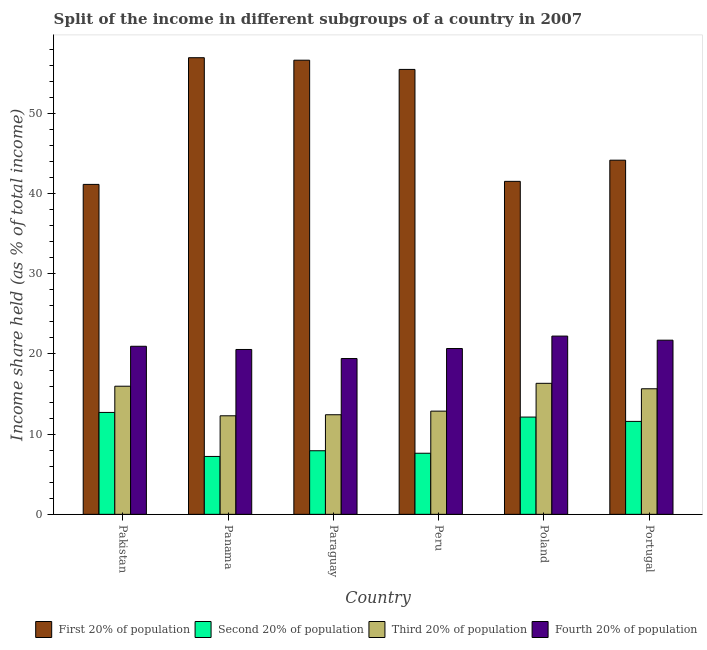How many groups of bars are there?
Keep it short and to the point. 6. Are the number of bars per tick equal to the number of legend labels?
Your response must be concise. Yes. How many bars are there on the 2nd tick from the left?
Ensure brevity in your answer.  4. How many bars are there on the 6th tick from the right?
Your answer should be very brief. 4. In how many cases, is the number of bars for a given country not equal to the number of legend labels?
Your answer should be very brief. 0. What is the share of the income held by third 20% of the population in Portugal?
Offer a terse response. 15.66. Across all countries, what is the maximum share of the income held by first 20% of the population?
Make the answer very short. 56.95. Across all countries, what is the minimum share of the income held by first 20% of the population?
Give a very brief answer. 41.15. In which country was the share of the income held by first 20% of the population maximum?
Your answer should be very brief. Panama. In which country was the share of the income held by first 20% of the population minimum?
Keep it short and to the point. Pakistan. What is the total share of the income held by fourth 20% of the population in the graph?
Your response must be concise. 125.58. What is the difference between the share of the income held by third 20% of the population in Panama and that in Peru?
Keep it short and to the point. -0.58. What is the difference between the share of the income held by second 20% of the population in Panama and the share of the income held by third 20% of the population in Pakistan?
Ensure brevity in your answer.  -8.76. What is the average share of the income held by fourth 20% of the population per country?
Make the answer very short. 20.93. What is the difference between the share of the income held by first 20% of the population and share of the income held by second 20% of the population in Portugal?
Your answer should be compact. 32.58. What is the ratio of the share of the income held by fourth 20% of the population in Pakistan to that in Panama?
Your response must be concise. 1.02. What is the difference between the highest and the second highest share of the income held by second 20% of the population?
Provide a succinct answer. 0.58. What is the difference between the highest and the lowest share of the income held by fourth 20% of the population?
Provide a succinct answer. 2.8. What does the 1st bar from the left in Peru represents?
Your answer should be very brief. First 20% of population. What does the 3rd bar from the right in Peru represents?
Provide a succinct answer. Second 20% of population. Is it the case that in every country, the sum of the share of the income held by first 20% of the population and share of the income held by second 20% of the population is greater than the share of the income held by third 20% of the population?
Offer a very short reply. Yes. How many bars are there?
Offer a terse response. 24. Are all the bars in the graph horizontal?
Give a very brief answer. No. How many countries are there in the graph?
Offer a very short reply. 6. What is the difference between two consecutive major ticks on the Y-axis?
Offer a very short reply. 10. Are the values on the major ticks of Y-axis written in scientific E-notation?
Your response must be concise. No. Does the graph contain grids?
Your answer should be compact. No. Where does the legend appear in the graph?
Provide a succinct answer. Bottom right. How many legend labels are there?
Offer a very short reply. 4. How are the legend labels stacked?
Offer a terse response. Horizontal. What is the title of the graph?
Make the answer very short. Split of the income in different subgroups of a country in 2007. What is the label or title of the Y-axis?
Your answer should be very brief. Income share held (as % of total income). What is the Income share held (as % of total income) in First 20% of population in Pakistan?
Your answer should be very brief. 41.15. What is the Income share held (as % of total income) in Second 20% of population in Pakistan?
Your answer should be very brief. 12.71. What is the Income share held (as % of total income) of Third 20% of population in Pakistan?
Keep it short and to the point. 15.98. What is the Income share held (as % of total income) in Fourth 20% of population in Pakistan?
Provide a succinct answer. 20.96. What is the Income share held (as % of total income) of First 20% of population in Panama?
Your answer should be compact. 56.95. What is the Income share held (as % of total income) of Second 20% of population in Panama?
Give a very brief answer. 7.22. What is the Income share held (as % of total income) in Third 20% of population in Panama?
Your answer should be very brief. 12.29. What is the Income share held (as % of total income) of Fourth 20% of population in Panama?
Provide a succinct answer. 20.56. What is the Income share held (as % of total income) of First 20% of population in Paraguay?
Keep it short and to the point. 56.64. What is the Income share held (as % of total income) in Second 20% of population in Paraguay?
Ensure brevity in your answer.  7.93. What is the Income share held (as % of total income) of Third 20% of population in Paraguay?
Offer a very short reply. 12.42. What is the Income share held (as % of total income) in Fourth 20% of population in Paraguay?
Provide a succinct answer. 19.43. What is the Income share held (as % of total income) in First 20% of population in Peru?
Keep it short and to the point. 55.49. What is the Income share held (as % of total income) of Second 20% of population in Peru?
Keep it short and to the point. 7.62. What is the Income share held (as % of total income) in Third 20% of population in Peru?
Keep it short and to the point. 12.87. What is the Income share held (as % of total income) in Fourth 20% of population in Peru?
Offer a terse response. 20.68. What is the Income share held (as % of total income) in First 20% of population in Poland?
Your response must be concise. 41.53. What is the Income share held (as % of total income) in Second 20% of population in Poland?
Your answer should be very brief. 12.13. What is the Income share held (as % of total income) of Third 20% of population in Poland?
Keep it short and to the point. 16.34. What is the Income share held (as % of total income) of Fourth 20% of population in Poland?
Make the answer very short. 22.23. What is the Income share held (as % of total income) in First 20% of population in Portugal?
Keep it short and to the point. 44.17. What is the Income share held (as % of total income) in Second 20% of population in Portugal?
Offer a terse response. 11.59. What is the Income share held (as % of total income) in Third 20% of population in Portugal?
Your answer should be compact. 15.66. What is the Income share held (as % of total income) in Fourth 20% of population in Portugal?
Give a very brief answer. 21.72. Across all countries, what is the maximum Income share held (as % of total income) in First 20% of population?
Offer a terse response. 56.95. Across all countries, what is the maximum Income share held (as % of total income) in Second 20% of population?
Ensure brevity in your answer.  12.71. Across all countries, what is the maximum Income share held (as % of total income) in Third 20% of population?
Keep it short and to the point. 16.34. Across all countries, what is the maximum Income share held (as % of total income) of Fourth 20% of population?
Offer a terse response. 22.23. Across all countries, what is the minimum Income share held (as % of total income) in First 20% of population?
Keep it short and to the point. 41.15. Across all countries, what is the minimum Income share held (as % of total income) of Second 20% of population?
Offer a terse response. 7.22. Across all countries, what is the minimum Income share held (as % of total income) of Third 20% of population?
Provide a short and direct response. 12.29. Across all countries, what is the minimum Income share held (as % of total income) in Fourth 20% of population?
Your answer should be compact. 19.43. What is the total Income share held (as % of total income) in First 20% of population in the graph?
Keep it short and to the point. 295.93. What is the total Income share held (as % of total income) in Second 20% of population in the graph?
Give a very brief answer. 59.2. What is the total Income share held (as % of total income) of Third 20% of population in the graph?
Give a very brief answer. 85.56. What is the total Income share held (as % of total income) in Fourth 20% of population in the graph?
Ensure brevity in your answer.  125.58. What is the difference between the Income share held (as % of total income) of First 20% of population in Pakistan and that in Panama?
Your answer should be very brief. -15.8. What is the difference between the Income share held (as % of total income) of Second 20% of population in Pakistan and that in Panama?
Your response must be concise. 5.49. What is the difference between the Income share held (as % of total income) in Third 20% of population in Pakistan and that in Panama?
Keep it short and to the point. 3.69. What is the difference between the Income share held (as % of total income) in First 20% of population in Pakistan and that in Paraguay?
Provide a succinct answer. -15.49. What is the difference between the Income share held (as % of total income) of Second 20% of population in Pakistan and that in Paraguay?
Keep it short and to the point. 4.78. What is the difference between the Income share held (as % of total income) of Third 20% of population in Pakistan and that in Paraguay?
Offer a very short reply. 3.56. What is the difference between the Income share held (as % of total income) in Fourth 20% of population in Pakistan and that in Paraguay?
Your answer should be compact. 1.53. What is the difference between the Income share held (as % of total income) of First 20% of population in Pakistan and that in Peru?
Your answer should be very brief. -14.34. What is the difference between the Income share held (as % of total income) in Second 20% of population in Pakistan and that in Peru?
Ensure brevity in your answer.  5.09. What is the difference between the Income share held (as % of total income) of Third 20% of population in Pakistan and that in Peru?
Your answer should be very brief. 3.11. What is the difference between the Income share held (as % of total income) in Fourth 20% of population in Pakistan and that in Peru?
Provide a succinct answer. 0.28. What is the difference between the Income share held (as % of total income) in First 20% of population in Pakistan and that in Poland?
Keep it short and to the point. -0.38. What is the difference between the Income share held (as % of total income) in Second 20% of population in Pakistan and that in Poland?
Ensure brevity in your answer.  0.58. What is the difference between the Income share held (as % of total income) in Third 20% of population in Pakistan and that in Poland?
Make the answer very short. -0.36. What is the difference between the Income share held (as % of total income) of Fourth 20% of population in Pakistan and that in Poland?
Provide a succinct answer. -1.27. What is the difference between the Income share held (as % of total income) of First 20% of population in Pakistan and that in Portugal?
Your response must be concise. -3.02. What is the difference between the Income share held (as % of total income) of Second 20% of population in Pakistan and that in Portugal?
Give a very brief answer. 1.12. What is the difference between the Income share held (as % of total income) of Third 20% of population in Pakistan and that in Portugal?
Provide a succinct answer. 0.32. What is the difference between the Income share held (as % of total income) in Fourth 20% of population in Pakistan and that in Portugal?
Offer a very short reply. -0.76. What is the difference between the Income share held (as % of total income) in First 20% of population in Panama and that in Paraguay?
Make the answer very short. 0.31. What is the difference between the Income share held (as % of total income) of Second 20% of population in Panama and that in Paraguay?
Give a very brief answer. -0.71. What is the difference between the Income share held (as % of total income) of Third 20% of population in Panama and that in Paraguay?
Your response must be concise. -0.13. What is the difference between the Income share held (as % of total income) in Fourth 20% of population in Panama and that in Paraguay?
Your answer should be compact. 1.13. What is the difference between the Income share held (as % of total income) in First 20% of population in Panama and that in Peru?
Your answer should be compact. 1.46. What is the difference between the Income share held (as % of total income) in Second 20% of population in Panama and that in Peru?
Your answer should be compact. -0.4. What is the difference between the Income share held (as % of total income) of Third 20% of population in Panama and that in Peru?
Your answer should be compact. -0.58. What is the difference between the Income share held (as % of total income) in Fourth 20% of population in Panama and that in Peru?
Offer a very short reply. -0.12. What is the difference between the Income share held (as % of total income) in First 20% of population in Panama and that in Poland?
Offer a very short reply. 15.42. What is the difference between the Income share held (as % of total income) in Second 20% of population in Panama and that in Poland?
Ensure brevity in your answer.  -4.91. What is the difference between the Income share held (as % of total income) in Third 20% of population in Panama and that in Poland?
Ensure brevity in your answer.  -4.05. What is the difference between the Income share held (as % of total income) in Fourth 20% of population in Panama and that in Poland?
Provide a short and direct response. -1.67. What is the difference between the Income share held (as % of total income) in First 20% of population in Panama and that in Portugal?
Keep it short and to the point. 12.78. What is the difference between the Income share held (as % of total income) of Second 20% of population in Panama and that in Portugal?
Make the answer very short. -4.37. What is the difference between the Income share held (as % of total income) of Third 20% of population in Panama and that in Portugal?
Provide a short and direct response. -3.37. What is the difference between the Income share held (as % of total income) of Fourth 20% of population in Panama and that in Portugal?
Your answer should be compact. -1.16. What is the difference between the Income share held (as % of total income) of First 20% of population in Paraguay and that in Peru?
Offer a terse response. 1.15. What is the difference between the Income share held (as % of total income) in Second 20% of population in Paraguay and that in Peru?
Provide a short and direct response. 0.31. What is the difference between the Income share held (as % of total income) of Third 20% of population in Paraguay and that in Peru?
Offer a very short reply. -0.45. What is the difference between the Income share held (as % of total income) in Fourth 20% of population in Paraguay and that in Peru?
Offer a terse response. -1.25. What is the difference between the Income share held (as % of total income) in First 20% of population in Paraguay and that in Poland?
Your answer should be very brief. 15.11. What is the difference between the Income share held (as % of total income) of Second 20% of population in Paraguay and that in Poland?
Give a very brief answer. -4.2. What is the difference between the Income share held (as % of total income) in Third 20% of population in Paraguay and that in Poland?
Ensure brevity in your answer.  -3.92. What is the difference between the Income share held (as % of total income) of First 20% of population in Paraguay and that in Portugal?
Give a very brief answer. 12.47. What is the difference between the Income share held (as % of total income) in Second 20% of population in Paraguay and that in Portugal?
Your response must be concise. -3.66. What is the difference between the Income share held (as % of total income) of Third 20% of population in Paraguay and that in Portugal?
Your answer should be very brief. -3.24. What is the difference between the Income share held (as % of total income) in Fourth 20% of population in Paraguay and that in Portugal?
Your answer should be very brief. -2.29. What is the difference between the Income share held (as % of total income) in First 20% of population in Peru and that in Poland?
Keep it short and to the point. 13.96. What is the difference between the Income share held (as % of total income) of Second 20% of population in Peru and that in Poland?
Your answer should be very brief. -4.51. What is the difference between the Income share held (as % of total income) in Third 20% of population in Peru and that in Poland?
Make the answer very short. -3.47. What is the difference between the Income share held (as % of total income) in Fourth 20% of population in Peru and that in Poland?
Keep it short and to the point. -1.55. What is the difference between the Income share held (as % of total income) in First 20% of population in Peru and that in Portugal?
Your answer should be very brief. 11.32. What is the difference between the Income share held (as % of total income) of Second 20% of population in Peru and that in Portugal?
Your answer should be compact. -3.97. What is the difference between the Income share held (as % of total income) of Third 20% of population in Peru and that in Portugal?
Provide a short and direct response. -2.79. What is the difference between the Income share held (as % of total income) of Fourth 20% of population in Peru and that in Portugal?
Make the answer very short. -1.04. What is the difference between the Income share held (as % of total income) in First 20% of population in Poland and that in Portugal?
Your answer should be compact. -2.64. What is the difference between the Income share held (as % of total income) in Second 20% of population in Poland and that in Portugal?
Keep it short and to the point. 0.54. What is the difference between the Income share held (as % of total income) in Third 20% of population in Poland and that in Portugal?
Keep it short and to the point. 0.68. What is the difference between the Income share held (as % of total income) in Fourth 20% of population in Poland and that in Portugal?
Your answer should be very brief. 0.51. What is the difference between the Income share held (as % of total income) in First 20% of population in Pakistan and the Income share held (as % of total income) in Second 20% of population in Panama?
Ensure brevity in your answer.  33.93. What is the difference between the Income share held (as % of total income) of First 20% of population in Pakistan and the Income share held (as % of total income) of Third 20% of population in Panama?
Make the answer very short. 28.86. What is the difference between the Income share held (as % of total income) of First 20% of population in Pakistan and the Income share held (as % of total income) of Fourth 20% of population in Panama?
Your answer should be very brief. 20.59. What is the difference between the Income share held (as % of total income) in Second 20% of population in Pakistan and the Income share held (as % of total income) in Third 20% of population in Panama?
Your answer should be very brief. 0.42. What is the difference between the Income share held (as % of total income) of Second 20% of population in Pakistan and the Income share held (as % of total income) of Fourth 20% of population in Panama?
Offer a terse response. -7.85. What is the difference between the Income share held (as % of total income) in Third 20% of population in Pakistan and the Income share held (as % of total income) in Fourth 20% of population in Panama?
Your answer should be very brief. -4.58. What is the difference between the Income share held (as % of total income) of First 20% of population in Pakistan and the Income share held (as % of total income) of Second 20% of population in Paraguay?
Your response must be concise. 33.22. What is the difference between the Income share held (as % of total income) in First 20% of population in Pakistan and the Income share held (as % of total income) in Third 20% of population in Paraguay?
Provide a succinct answer. 28.73. What is the difference between the Income share held (as % of total income) in First 20% of population in Pakistan and the Income share held (as % of total income) in Fourth 20% of population in Paraguay?
Offer a terse response. 21.72. What is the difference between the Income share held (as % of total income) in Second 20% of population in Pakistan and the Income share held (as % of total income) in Third 20% of population in Paraguay?
Offer a very short reply. 0.29. What is the difference between the Income share held (as % of total income) of Second 20% of population in Pakistan and the Income share held (as % of total income) of Fourth 20% of population in Paraguay?
Your answer should be very brief. -6.72. What is the difference between the Income share held (as % of total income) in Third 20% of population in Pakistan and the Income share held (as % of total income) in Fourth 20% of population in Paraguay?
Ensure brevity in your answer.  -3.45. What is the difference between the Income share held (as % of total income) in First 20% of population in Pakistan and the Income share held (as % of total income) in Second 20% of population in Peru?
Ensure brevity in your answer.  33.53. What is the difference between the Income share held (as % of total income) in First 20% of population in Pakistan and the Income share held (as % of total income) in Third 20% of population in Peru?
Offer a very short reply. 28.28. What is the difference between the Income share held (as % of total income) in First 20% of population in Pakistan and the Income share held (as % of total income) in Fourth 20% of population in Peru?
Offer a very short reply. 20.47. What is the difference between the Income share held (as % of total income) in Second 20% of population in Pakistan and the Income share held (as % of total income) in Third 20% of population in Peru?
Provide a succinct answer. -0.16. What is the difference between the Income share held (as % of total income) of Second 20% of population in Pakistan and the Income share held (as % of total income) of Fourth 20% of population in Peru?
Give a very brief answer. -7.97. What is the difference between the Income share held (as % of total income) in First 20% of population in Pakistan and the Income share held (as % of total income) in Second 20% of population in Poland?
Your answer should be very brief. 29.02. What is the difference between the Income share held (as % of total income) of First 20% of population in Pakistan and the Income share held (as % of total income) of Third 20% of population in Poland?
Your answer should be very brief. 24.81. What is the difference between the Income share held (as % of total income) in First 20% of population in Pakistan and the Income share held (as % of total income) in Fourth 20% of population in Poland?
Your answer should be compact. 18.92. What is the difference between the Income share held (as % of total income) in Second 20% of population in Pakistan and the Income share held (as % of total income) in Third 20% of population in Poland?
Offer a terse response. -3.63. What is the difference between the Income share held (as % of total income) in Second 20% of population in Pakistan and the Income share held (as % of total income) in Fourth 20% of population in Poland?
Your answer should be compact. -9.52. What is the difference between the Income share held (as % of total income) of Third 20% of population in Pakistan and the Income share held (as % of total income) of Fourth 20% of population in Poland?
Ensure brevity in your answer.  -6.25. What is the difference between the Income share held (as % of total income) in First 20% of population in Pakistan and the Income share held (as % of total income) in Second 20% of population in Portugal?
Your response must be concise. 29.56. What is the difference between the Income share held (as % of total income) in First 20% of population in Pakistan and the Income share held (as % of total income) in Third 20% of population in Portugal?
Provide a succinct answer. 25.49. What is the difference between the Income share held (as % of total income) of First 20% of population in Pakistan and the Income share held (as % of total income) of Fourth 20% of population in Portugal?
Offer a very short reply. 19.43. What is the difference between the Income share held (as % of total income) of Second 20% of population in Pakistan and the Income share held (as % of total income) of Third 20% of population in Portugal?
Provide a succinct answer. -2.95. What is the difference between the Income share held (as % of total income) in Second 20% of population in Pakistan and the Income share held (as % of total income) in Fourth 20% of population in Portugal?
Provide a succinct answer. -9.01. What is the difference between the Income share held (as % of total income) in Third 20% of population in Pakistan and the Income share held (as % of total income) in Fourth 20% of population in Portugal?
Make the answer very short. -5.74. What is the difference between the Income share held (as % of total income) in First 20% of population in Panama and the Income share held (as % of total income) in Second 20% of population in Paraguay?
Your response must be concise. 49.02. What is the difference between the Income share held (as % of total income) in First 20% of population in Panama and the Income share held (as % of total income) in Third 20% of population in Paraguay?
Your answer should be very brief. 44.53. What is the difference between the Income share held (as % of total income) in First 20% of population in Panama and the Income share held (as % of total income) in Fourth 20% of population in Paraguay?
Offer a very short reply. 37.52. What is the difference between the Income share held (as % of total income) in Second 20% of population in Panama and the Income share held (as % of total income) in Third 20% of population in Paraguay?
Provide a succinct answer. -5.2. What is the difference between the Income share held (as % of total income) in Second 20% of population in Panama and the Income share held (as % of total income) in Fourth 20% of population in Paraguay?
Make the answer very short. -12.21. What is the difference between the Income share held (as % of total income) of Third 20% of population in Panama and the Income share held (as % of total income) of Fourth 20% of population in Paraguay?
Provide a short and direct response. -7.14. What is the difference between the Income share held (as % of total income) in First 20% of population in Panama and the Income share held (as % of total income) in Second 20% of population in Peru?
Provide a succinct answer. 49.33. What is the difference between the Income share held (as % of total income) of First 20% of population in Panama and the Income share held (as % of total income) of Third 20% of population in Peru?
Offer a very short reply. 44.08. What is the difference between the Income share held (as % of total income) of First 20% of population in Panama and the Income share held (as % of total income) of Fourth 20% of population in Peru?
Give a very brief answer. 36.27. What is the difference between the Income share held (as % of total income) of Second 20% of population in Panama and the Income share held (as % of total income) of Third 20% of population in Peru?
Offer a very short reply. -5.65. What is the difference between the Income share held (as % of total income) in Second 20% of population in Panama and the Income share held (as % of total income) in Fourth 20% of population in Peru?
Offer a very short reply. -13.46. What is the difference between the Income share held (as % of total income) in Third 20% of population in Panama and the Income share held (as % of total income) in Fourth 20% of population in Peru?
Give a very brief answer. -8.39. What is the difference between the Income share held (as % of total income) in First 20% of population in Panama and the Income share held (as % of total income) in Second 20% of population in Poland?
Your answer should be very brief. 44.82. What is the difference between the Income share held (as % of total income) in First 20% of population in Panama and the Income share held (as % of total income) in Third 20% of population in Poland?
Offer a very short reply. 40.61. What is the difference between the Income share held (as % of total income) of First 20% of population in Panama and the Income share held (as % of total income) of Fourth 20% of population in Poland?
Give a very brief answer. 34.72. What is the difference between the Income share held (as % of total income) of Second 20% of population in Panama and the Income share held (as % of total income) of Third 20% of population in Poland?
Ensure brevity in your answer.  -9.12. What is the difference between the Income share held (as % of total income) in Second 20% of population in Panama and the Income share held (as % of total income) in Fourth 20% of population in Poland?
Offer a very short reply. -15.01. What is the difference between the Income share held (as % of total income) of Third 20% of population in Panama and the Income share held (as % of total income) of Fourth 20% of population in Poland?
Your response must be concise. -9.94. What is the difference between the Income share held (as % of total income) of First 20% of population in Panama and the Income share held (as % of total income) of Second 20% of population in Portugal?
Offer a very short reply. 45.36. What is the difference between the Income share held (as % of total income) in First 20% of population in Panama and the Income share held (as % of total income) in Third 20% of population in Portugal?
Keep it short and to the point. 41.29. What is the difference between the Income share held (as % of total income) in First 20% of population in Panama and the Income share held (as % of total income) in Fourth 20% of population in Portugal?
Provide a short and direct response. 35.23. What is the difference between the Income share held (as % of total income) of Second 20% of population in Panama and the Income share held (as % of total income) of Third 20% of population in Portugal?
Your answer should be compact. -8.44. What is the difference between the Income share held (as % of total income) of Third 20% of population in Panama and the Income share held (as % of total income) of Fourth 20% of population in Portugal?
Give a very brief answer. -9.43. What is the difference between the Income share held (as % of total income) of First 20% of population in Paraguay and the Income share held (as % of total income) of Second 20% of population in Peru?
Your answer should be very brief. 49.02. What is the difference between the Income share held (as % of total income) of First 20% of population in Paraguay and the Income share held (as % of total income) of Third 20% of population in Peru?
Provide a short and direct response. 43.77. What is the difference between the Income share held (as % of total income) of First 20% of population in Paraguay and the Income share held (as % of total income) of Fourth 20% of population in Peru?
Offer a very short reply. 35.96. What is the difference between the Income share held (as % of total income) in Second 20% of population in Paraguay and the Income share held (as % of total income) in Third 20% of population in Peru?
Offer a very short reply. -4.94. What is the difference between the Income share held (as % of total income) of Second 20% of population in Paraguay and the Income share held (as % of total income) of Fourth 20% of population in Peru?
Ensure brevity in your answer.  -12.75. What is the difference between the Income share held (as % of total income) in Third 20% of population in Paraguay and the Income share held (as % of total income) in Fourth 20% of population in Peru?
Ensure brevity in your answer.  -8.26. What is the difference between the Income share held (as % of total income) of First 20% of population in Paraguay and the Income share held (as % of total income) of Second 20% of population in Poland?
Provide a succinct answer. 44.51. What is the difference between the Income share held (as % of total income) in First 20% of population in Paraguay and the Income share held (as % of total income) in Third 20% of population in Poland?
Keep it short and to the point. 40.3. What is the difference between the Income share held (as % of total income) of First 20% of population in Paraguay and the Income share held (as % of total income) of Fourth 20% of population in Poland?
Offer a very short reply. 34.41. What is the difference between the Income share held (as % of total income) of Second 20% of population in Paraguay and the Income share held (as % of total income) of Third 20% of population in Poland?
Your answer should be very brief. -8.41. What is the difference between the Income share held (as % of total income) of Second 20% of population in Paraguay and the Income share held (as % of total income) of Fourth 20% of population in Poland?
Your response must be concise. -14.3. What is the difference between the Income share held (as % of total income) in Third 20% of population in Paraguay and the Income share held (as % of total income) in Fourth 20% of population in Poland?
Ensure brevity in your answer.  -9.81. What is the difference between the Income share held (as % of total income) of First 20% of population in Paraguay and the Income share held (as % of total income) of Second 20% of population in Portugal?
Ensure brevity in your answer.  45.05. What is the difference between the Income share held (as % of total income) in First 20% of population in Paraguay and the Income share held (as % of total income) in Third 20% of population in Portugal?
Your response must be concise. 40.98. What is the difference between the Income share held (as % of total income) in First 20% of population in Paraguay and the Income share held (as % of total income) in Fourth 20% of population in Portugal?
Offer a terse response. 34.92. What is the difference between the Income share held (as % of total income) in Second 20% of population in Paraguay and the Income share held (as % of total income) in Third 20% of population in Portugal?
Provide a short and direct response. -7.73. What is the difference between the Income share held (as % of total income) in Second 20% of population in Paraguay and the Income share held (as % of total income) in Fourth 20% of population in Portugal?
Provide a succinct answer. -13.79. What is the difference between the Income share held (as % of total income) in Third 20% of population in Paraguay and the Income share held (as % of total income) in Fourth 20% of population in Portugal?
Make the answer very short. -9.3. What is the difference between the Income share held (as % of total income) in First 20% of population in Peru and the Income share held (as % of total income) in Second 20% of population in Poland?
Ensure brevity in your answer.  43.36. What is the difference between the Income share held (as % of total income) of First 20% of population in Peru and the Income share held (as % of total income) of Third 20% of population in Poland?
Ensure brevity in your answer.  39.15. What is the difference between the Income share held (as % of total income) of First 20% of population in Peru and the Income share held (as % of total income) of Fourth 20% of population in Poland?
Give a very brief answer. 33.26. What is the difference between the Income share held (as % of total income) of Second 20% of population in Peru and the Income share held (as % of total income) of Third 20% of population in Poland?
Provide a short and direct response. -8.72. What is the difference between the Income share held (as % of total income) in Second 20% of population in Peru and the Income share held (as % of total income) in Fourth 20% of population in Poland?
Offer a terse response. -14.61. What is the difference between the Income share held (as % of total income) of Third 20% of population in Peru and the Income share held (as % of total income) of Fourth 20% of population in Poland?
Provide a short and direct response. -9.36. What is the difference between the Income share held (as % of total income) of First 20% of population in Peru and the Income share held (as % of total income) of Second 20% of population in Portugal?
Keep it short and to the point. 43.9. What is the difference between the Income share held (as % of total income) of First 20% of population in Peru and the Income share held (as % of total income) of Third 20% of population in Portugal?
Your answer should be compact. 39.83. What is the difference between the Income share held (as % of total income) in First 20% of population in Peru and the Income share held (as % of total income) in Fourth 20% of population in Portugal?
Keep it short and to the point. 33.77. What is the difference between the Income share held (as % of total income) in Second 20% of population in Peru and the Income share held (as % of total income) in Third 20% of population in Portugal?
Give a very brief answer. -8.04. What is the difference between the Income share held (as % of total income) of Second 20% of population in Peru and the Income share held (as % of total income) of Fourth 20% of population in Portugal?
Make the answer very short. -14.1. What is the difference between the Income share held (as % of total income) of Third 20% of population in Peru and the Income share held (as % of total income) of Fourth 20% of population in Portugal?
Keep it short and to the point. -8.85. What is the difference between the Income share held (as % of total income) in First 20% of population in Poland and the Income share held (as % of total income) in Second 20% of population in Portugal?
Ensure brevity in your answer.  29.94. What is the difference between the Income share held (as % of total income) of First 20% of population in Poland and the Income share held (as % of total income) of Third 20% of population in Portugal?
Provide a succinct answer. 25.87. What is the difference between the Income share held (as % of total income) of First 20% of population in Poland and the Income share held (as % of total income) of Fourth 20% of population in Portugal?
Keep it short and to the point. 19.81. What is the difference between the Income share held (as % of total income) in Second 20% of population in Poland and the Income share held (as % of total income) in Third 20% of population in Portugal?
Your response must be concise. -3.53. What is the difference between the Income share held (as % of total income) in Second 20% of population in Poland and the Income share held (as % of total income) in Fourth 20% of population in Portugal?
Make the answer very short. -9.59. What is the difference between the Income share held (as % of total income) of Third 20% of population in Poland and the Income share held (as % of total income) of Fourth 20% of population in Portugal?
Offer a terse response. -5.38. What is the average Income share held (as % of total income) in First 20% of population per country?
Keep it short and to the point. 49.32. What is the average Income share held (as % of total income) of Second 20% of population per country?
Ensure brevity in your answer.  9.87. What is the average Income share held (as % of total income) in Third 20% of population per country?
Provide a short and direct response. 14.26. What is the average Income share held (as % of total income) of Fourth 20% of population per country?
Offer a very short reply. 20.93. What is the difference between the Income share held (as % of total income) of First 20% of population and Income share held (as % of total income) of Second 20% of population in Pakistan?
Give a very brief answer. 28.44. What is the difference between the Income share held (as % of total income) of First 20% of population and Income share held (as % of total income) of Third 20% of population in Pakistan?
Make the answer very short. 25.17. What is the difference between the Income share held (as % of total income) in First 20% of population and Income share held (as % of total income) in Fourth 20% of population in Pakistan?
Offer a terse response. 20.19. What is the difference between the Income share held (as % of total income) of Second 20% of population and Income share held (as % of total income) of Third 20% of population in Pakistan?
Offer a terse response. -3.27. What is the difference between the Income share held (as % of total income) of Second 20% of population and Income share held (as % of total income) of Fourth 20% of population in Pakistan?
Your answer should be compact. -8.25. What is the difference between the Income share held (as % of total income) in Third 20% of population and Income share held (as % of total income) in Fourth 20% of population in Pakistan?
Your response must be concise. -4.98. What is the difference between the Income share held (as % of total income) in First 20% of population and Income share held (as % of total income) in Second 20% of population in Panama?
Make the answer very short. 49.73. What is the difference between the Income share held (as % of total income) of First 20% of population and Income share held (as % of total income) of Third 20% of population in Panama?
Your answer should be very brief. 44.66. What is the difference between the Income share held (as % of total income) of First 20% of population and Income share held (as % of total income) of Fourth 20% of population in Panama?
Give a very brief answer. 36.39. What is the difference between the Income share held (as % of total income) of Second 20% of population and Income share held (as % of total income) of Third 20% of population in Panama?
Your answer should be compact. -5.07. What is the difference between the Income share held (as % of total income) in Second 20% of population and Income share held (as % of total income) in Fourth 20% of population in Panama?
Give a very brief answer. -13.34. What is the difference between the Income share held (as % of total income) in Third 20% of population and Income share held (as % of total income) in Fourth 20% of population in Panama?
Offer a very short reply. -8.27. What is the difference between the Income share held (as % of total income) of First 20% of population and Income share held (as % of total income) of Second 20% of population in Paraguay?
Give a very brief answer. 48.71. What is the difference between the Income share held (as % of total income) in First 20% of population and Income share held (as % of total income) in Third 20% of population in Paraguay?
Offer a terse response. 44.22. What is the difference between the Income share held (as % of total income) of First 20% of population and Income share held (as % of total income) of Fourth 20% of population in Paraguay?
Your answer should be compact. 37.21. What is the difference between the Income share held (as % of total income) in Second 20% of population and Income share held (as % of total income) in Third 20% of population in Paraguay?
Keep it short and to the point. -4.49. What is the difference between the Income share held (as % of total income) of Third 20% of population and Income share held (as % of total income) of Fourth 20% of population in Paraguay?
Your answer should be very brief. -7.01. What is the difference between the Income share held (as % of total income) of First 20% of population and Income share held (as % of total income) of Second 20% of population in Peru?
Make the answer very short. 47.87. What is the difference between the Income share held (as % of total income) of First 20% of population and Income share held (as % of total income) of Third 20% of population in Peru?
Your answer should be very brief. 42.62. What is the difference between the Income share held (as % of total income) in First 20% of population and Income share held (as % of total income) in Fourth 20% of population in Peru?
Offer a very short reply. 34.81. What is the difference between the Income share held (as % of total income) of Second 20% of population and Income share held (as % of total income) of Third 20% of population in Peru?
Offer a terse response. -5.25. What is the difference between the Income share held (as % of total income) in Second 20% of population and Income share held (as % of total income) in Fourth 20% of population in Peru?
Your answer should be very brief. -13.06. What is the difference between the Income share held (as % of total income) of Third 20% of population and Income share held (as % of total income) of Fourth 20% of population in Peru?
Give a very brief answer. -7.81. What is the difference between the Income share held (as % of total income) in First 20% of population and Income share held (as % of total income) in Second 20% of population in Poland?
Your answer should be compact. 29.4. What is the difference between the Income share held (as % of total income) of First 20% of population and Income share held (as % of total income) of Third 20% of population in Poland?
Offer a very short reply. 25.19. What is the difference between the Income share held (as % of total income) in First 20% of population and Income share held (as % of total income) in Fourth 20% of population in Poland?
Make the answer very short. 19.3. What is the difference between the Income share held (as % of total income) of Second 20% of population and Income share held (as % of total income) of Third 20% of population in Poland?
Your answer should be compact. -4.21. What is the difference between the Income share held (as % of total income) in Second 20% of population and Income share held (as % of total income) in Fourth 20% of population in Poland?
Provide a short and direct response. -10.1. What is the difference between the Income share held (as % of total income) in Third 20% of population and Income share held (as % of total income) in Fourth 20% of population in Poland?
Provide a succinct answer. -5.89. What is the difference between the Income share held (as % of total income) of First 20% of population and Income share held (as % of total income) of Second 20% of population in Portugal?
Your answer should be very brief. 32.58. What is the difference between the Income share held (as % of total income) of First 20% of population and Income share held (as % of total income) of Third 20% of population in Portugal?
Ensure brevity in your answer.  28.51. What is the difference between the Income share held (as % of total income) in First 20% of population and Income share held (as % of total income) in Fourth 20% of population in Portugal?
Keep it short and to the point. 22.45. What is the difference between the Income share held (as % of total income) of Second 20% of population and Income share held (as % of total income) of Third 20% of population in Portugal?
Provide a succinct answer. -4.07. What is the difference between the Income share held (as % of total income) in Second 20% of population and Income share held (as % of total income) in Fourth 20% of population in Portugal?
Provide a succinct answer. -10.13. What is the difference between the Income share held (as % of total income) of Third 20% of population and Income share held (as % of total income) of Fourth 20% of population in Portugal?
Give a very brief answer. -6.06. What is the ratio of the Income share held (as % of total income) of First 20% of population in Pakistan to that in Panama?
Offer a very short reply. 0.72. What is the ratio of the Income share held (as % of total income) in Second 20% of population in Pakistan to that in Panama?
Offer a very short reply. 1.76. What is the ratio of the Income share held (as % of total income) of Third 20% of population in Pakistan to that in Panama?
Your answer should be very brief. 1.3. What is the ratio of the Income share held (as % of total income) in Fourth 20% of population in Pakistan to that in Panama?
Your response must be concise. 1.02. What is the ratio of the Income share held (as % of total income) of First 20% of population in Pakistan to that in Paraguay?
Your response must be concise. 0.73. What is the ratio of the Income share held (as % of total income) in Second 20% of population in Pakistan to that in Paraguay?
Offer a terse response. 1.6. What is the ratio of the Income share held (as % of total income) of Third 20% of population in Pakistan to that in Paraguay?
Keep it short and to the point. 1.29. What is the ratio of the Income share held (as % of total income) in Fourth 20% of population in Pakistan to that in Paraguay?
Your answer should be compact. 1.08. What is the ratio of the Income share held (as % of total income) in First 20% of population in Pakistan to that in Peru?
Provide a short and direct response. 0.74. What is the ratio of the Income share held (as % of total income) in Second 20% of population in Pakistan to that in Peru?
Provide a short and direct response. 1.67. What is the ratio of the Income share held (as % of total income) in Third 20% of population in Pakistan to that in Peru?
Make the answer very short. 1.24. What is the ratio of the Income share held (as % of total income) of Fourth 20% of population in Pakistan to that in Peru?
Offer a terse response. 1.01. What is the ratio of the Income share held (as % of total income) in Second 20% of population in Pakistan to that in Poland?
Give a very brief answer. 1.05. What is the ratio of the Income share held (as % of total income) of Fourth 20% of population in Pakistan to that in Poland?
Your answer should be very brief. 0.94. What is the ratio of the Income share held (as % of total income) in First 20% of population in Pakistan to that in Portugal?
Your answer should be very brief. 0.93. What is the ratio of the Income share held (as % of total income) of Second 20% of population in Pakistan to that in Portugal?
Provide a succinct answer. 1.1. What is the ratio of the Income share held (as % of total income) in Third 20% of population in Pakistan to that in Portugal?
Your response must be concise. 1.02. What is the ratio of the Income share held (as % of total income) in Second 20% of population in Panama to that in Paraguay?
Ensure brevity in your answer.  0.91. What is the ratio of the Income share held (as % of total income) of Fourth 20% of population in Panama to that in Paraguay?
Offer a very short reply. 1.06. What is the ratio of the Income share held (as % of total income) in First 20% of population in Panama to that in Peru?
Offer a terse response. 1.03. What is the ratio of the Income share held (as % of total income) of Second 20% of population in Panama to that in Peru?
Keep it short and to the point. 0.95. What is the ratio of the Income share held (as % of total income) in Third 20% of population in Panama to that in Peru?
Your response must be concise. 0.95. What is the ratio of the Income share held (as % of total income) in First 20% of population in Panama to that in Poland?
Your answer should be very brief. 1.37. What is the ratio of the Income share held (as % of total income) in Second 20% of population in Panama to that in Poland?
Make the answer very short. 0.6. What is the ratio of the Income share held (as % of total income) in Third 20% of population in Panama to that in Poland?
Your response must be concise. 0.75. What is the ratio of the Income share held (as % of total income) in Fourth 20% of population in Panama to that in Poland?
Provide a succinct answer. 0.92. What is the ratio of the Income share held (as % of total income) in First 20% of population in Panama to that in Portugal?
Offer a terse response. 1.29. What is the ratio of the Income share held (as % of total income) of Second 20% of population in Panama to that in Portugal?
Your response must be concise. 0.62. What is the ratio of the Income share held (as % of total income) in Third 20% of population in Panama to that in Portugal?
Your response must be concise. 0.78. What is the ratio of the Income share held (as % of total income) in Fourth 20% of population in Panama to that in Portugal?
Give a very brief answer. 0.95. What is the ratio of the Income share held (as % of total income) of First 20% of population in Paraguay to that in Peru?
Ensure brevity in your answer.  1.02. What is the ratio of the Income share held (as % of total income) in Second 20% of population in Paraguay to that in Peru?
Make the answer very short. 1.04. What is the ratio of the Income share held (as % of total income) of Fourth 20% of population in Paraguay to that in Peru?
Offer a very short reply. 0.94. What is the ratio of the Income share held (as % of total income) in First 20% of population in Paraguay to that in Poland?
Ensure brevity in your answer.  1.36. What is the ratio of the Income share held (as % of total income) of Second 20% of population in Paraguay to that in Poland?
Provide a succinct answer. 0.65. What is the ratio of the Income share held (as % of total income) in Third 20% of population in Paraguay to that in Poland?
Make the answer very short. 0.76. What is the ratio of the Income share held (as % of total income) of Fourth 20% of population in Paraguay to that in Poland?
Your response must be concise. 0.87. What is the ratio of the Income share held (as % of total income) in First 20% of population in Paraguay to that in Portugal?
Ensure brevity in your answer.  1.28. What is the ratio of the Income share held (as % of total income) of Second 20% of population in Paraguay to that in Portugal?
Provide a succinct answer. 0.68. What is the ratio of the Income share held (as % of total income) in Third 20% of population in Paraguay to that in Portugal?
Offer a terse response. 0.79. What is the ratio of the Income share held (as % of total income) of Fourth 20% of population in Paraguay to that in Portugal?
Ensure brevity in your answer.  0.89. What is the ratio of the Income share held (as % of total income) of First 20% of population in Peru to that in Poland?
Offer a very short reply. 1.34. What is the ratio of the Income share held (as % of total income) in Second 20% of population in Peru to that in Poland?
Provide a succinct answer. 0.63. What is the ratio of the Income share held (as % of total income) in Third 20% of population in Peru to that in Poland?
Ensure brevity in your answer.  0.79. What is the ratio of the Income share held (as % of total income) in Fourth 20% of population in Peru to that in Poland?
Keep it short and to the point. 0.93. What is the ratio of the Income share held (as % of total income) in First 20% of population in Peru to that in Portugal?
Make the answer very short. 1.26. What is the ratio of the Income share held (as % of total income) of Second 20% of population in Peru to that in Portugal?
Provide a short and direct response. 0.66. What is the ratio of the Income share held (as % of total income) in Third 20% of population in Peru to that in Portugal?
Your answer should be compact. 0.82. What is the ratio of the Income share held (as % of total income) in Fourth 20% of population in Peru to that in Portugal?
Give a very brief answer. 0.95. What is the ratio of the Income share held (as % of total income) in First 20% of population in Poland to that in Portugal?
Your answer should be compact. 0.94. What is the ratio of the Income share held (as % of total income) of Second 20% of population in Poland to that in Portugal?
Ensure brevity in your answer.  1.05. What is the ratio of the Income share held (as % of total income) in Third 20% of population in Poland to that in Portugal?
Provide a succinct answer. 1.04. What is the ratio of the Income share held (as % of total income) of Fourth 20% of population in Poland to that in Portugal?
Make the answer very short. 1.02. What is the difference between the highest and the second highest Income share held (as % of total income) of First 20% of population?
Provide a short and direct response. 0.31. What is the difference between the highest and the second highest Income share held (as % of total income) of Second 20% of population?
Keep it short and to the point. 0.58. What is the difference between the highest and the second highest Income share held (as % of total income) of Third 20% of population?
Provide a short and direct response. 0.36. What is the difference between the highest and the second highest Income share held (as % of total income) in Fourth 20% of population?
Make the answer very short. 0.51. What is the difference between the highest and the lowest Income share held (as % of total income) of Second 20% of population?
Provide a short and direct response. 5.49. What is the difference between the highest and the lowest Income share held (as % of total income) in Third 20% of population?
Offer a very short reply. 4.05. What is the difference between the highest and the lowest Income share held (as % of total income) of Fourth 20% of population?
Keep it short and to the point. 2.8. 